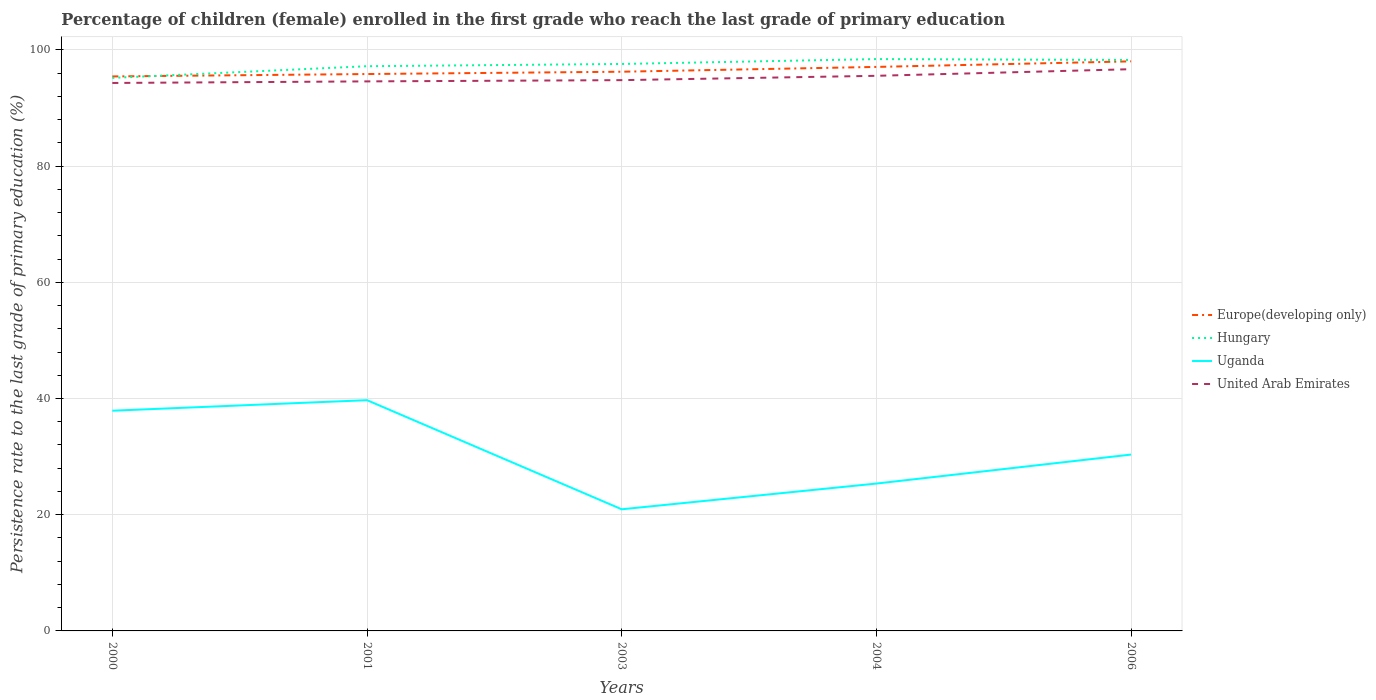Is the number of lines equal to the number of legend labels?
Make the answer very short. Yes. Across all years, what is the maximum persistence rate of children in Hungary?
Ensure brevity in your answer.  95.18. In which year was the persistence rate of children in United Arab Emirates maximum?
Give a very brief answer. 2000. What is the total persistence rate of children in United Arab Emirates in the graph?
Your answer should be compact. -0.75. What is the difference between the highest and the second highest persistence rate of children in Europe(developing only)?
Offer a terse response. 2.59. How many lines are there?
Offer a terse response. 4. How many years are there in the graph?
Ensure brevity in your answer.  5. Are the values on the major ticks of Y-axis written in scientific E-notation?
Your answer should be compact. No. Where does the legend appear in the graph?
Your answer should be very brief. Center right. What is the title of the graph?
Offer a very short reply. Percentage of children (female) enrolled in the first grade who reach the last grade of primary education. Does "Burundi" appear as one of the legend labels in the graph?
Offer a very short reply. No. What is the label or title of the X-axis?
Give a very brief answer. Years. What is the label or title of the Y-axis?
Your answer should be very brief. Persistence rate to the last grade of primary education (%). What is the Persistence rate to the last grade of primary education (%) of Europe(developing only) in 2000?
Your answer should be compact. 95.44. What is the Persistence rate to the last grade of primary education (%) in Hungary in 2000?
Your answer should be very brief. 95.18. What is the Persistence rate to the last grade of primary education (%) of Uganda in 2000?
Make the answer very short. 37.9. What is the Persistence rate to the last grade of primary education (%) in United Arab Emirates in 2000?
Offer a very short reply. 94.31. What is the Persistence rate to the last grade of primary education (%) in Europe(developing only) in 2001?
Your answer should be very brief. 95.85. What is the Persistence rate to the last grade of primary education (%) of Hungary in 2001?
Ensure brevity in your answer.  97.19. What is the Persistence rate to the last grade of primary education (%) in Uganda in 2001?
Provide a short and direct response. 39.72. What is the Persistence rate to the last grade of primary education (%) of United Arab Emirates in 2001?
Your answer should be very brief. 94.58. What is the Persistence rate to the last grade of primary education (%) in Europe(developing only) in 2003?
Provide a succinct answer. 96.25. What is the Persistence rate to the last grade of primary education (%) in Hungary in 2003?
Give a very brief answer. 97.58. What is the Persistence rate to the last grade of primary education (%) in Uganda in 2003?
Give a very brief answer. 20.93. What is the Persistence rate to the last grade of primary education (%) in United Arab Emirates in 2003?
Your response must be concise. 94.8. What is the Persistence rate to the last grade of primary education (%) in Europe(developing only) in 2004?
Keep it short and to the point. 97.07. What is the Persistence rate to the last grade of primary education (%) in Hungary in 2004?
Your answer should be compact. 98.42. What is the Persistence rate to the last grade of primary education (%) of Uganda in 2004?
Keep it short and to the point. 25.36. What is the Persistence rate to the last grade of primary education (%) of United Arab Emirates in 2004?
Provide a short and direct response. 95.54. What is the Persistence rate to the last grade of primary education (%) in Europe(developing only) in 2006?
Provide a succinct answer. 98.03. What is the Persistence rate to the last grade of primary education (%) in Hungary in 2006?
Provide a succinct answer. 98.27. What is the Persistence rate to the last grade of primary education (%) of Uganda in 2006?
Your answer should be compact. 30.35. What is the Persistence rate to the last grade of primary education (%) in United Arab Emirates in 2006?
Give a very brief answer. 96.68. Across all years, what is the maximum Persistence rate to the last grade of primary education (%) of Europe(developing only)?
Your answer should be very brief. 98.03. Across all years, what is the maximum Persistence rate to the last grade of primary education (%) in Hungary?
Your answer should be very brief. 98.42. Across all years, what is the maximum Persistence rate to the last grade of primary education (%) of Uganda?
Make the answer very short. 39.72. Across all years, what is the maximum Persistence rate to the last grade of primary education (%) of United Arab Emirates?
Give a very brief answer. 96.68. Across all years, what is the minimum Persistence rate to the last grade of primary education (%) of Europe(developing only)?
Give a very brief answer. 95.44. Across all years, what is the minimum Persistence rate to the last grade of primary education (%) of Hungary?
Make the answer very short. 95.18. Across all years, what is the minimum Persistence rate to the last grade of primary education (%) in Uganda?
Provide a succinct answer. 20.93. Across all years, what is the minimum Persistence rate to the last grade of primary education (%) in United Arab Emirates?
Provide a succinct answer. 94.31. What is the total Persistence rate to the last grade of primary education (%) in Europe(developing only) in the graph?
Give a very brief answer. 482.63. What is the total Persistence rate to the last grade of primary education (%) in Hungary in the graph?
Your response must be concise. 486.65. What is the total Persistence rate to the last grade of primary education (%) in Uganda in the graph?
Keep it short and to the point. 154.27. What is the total Persistence rate to the last grade of primary education (%) in United Arab Emirates in the graph?
Your answer should be very brief. 475.91. What is the difference between the Persistence rate to the last grade of primary education (%) in Europe(developing only) in 2000 and that in 2001?
Ensure brevity in your answer.  -0.41. What is the difference between the Persistence rate to the last grade of primary education (%) of Hungary in 2000 and that in 2001?
Offer a very short reply. -2.01. What is the difference between the Persistence rate to the last grade of primary education (%) in Uganda in 2000 and that in 2001?
Ensure brevity in your answer.  -1.82. What is the difference between the Persistence rate to the last grade of primary education (%) in United Arab Emirates in 2000 and that in 2001?
Offer a very short reply. -0.27. What is the difference between the Persistence rate to the last grade of primary education (%) in Europe(developing only) in 2000 and that in 2003?
Provide a succinct answer. -0.81. What is the difference between the Persistence rate to the last grade of primary education (%) of Hungary in 2000 and that in 2003?
Provide a short and direct response. -2.4. What is the difference between the Persistence rate to the last grade of primary education (%) in Uganda in 2000 and that in 2003?
Your answer should be compact. 16.96. What is the difference between the Persistence rate to the last grade of primary education (%) in United Arab Emirates in 2000 and that in 2003?
Give a very brief answer. -0.49. What is the difference between the Persistence rate to the last grade of primary education (%) of Europe(developing only) in 2000 and that in 2004?
Offer a terse response. -1.64. What is the difference between the Persistence rate to the last grade of primary education (%) in Hungary in 2000 and that in 2004?
Ensure brevity in your answer.  -3.24. What is the difference between the Persistence rate to the last grade of primary education (%) in Uganda in 2000 and that in 2004?
Your response must be concise. 12.53. What is the difference between the Persistence rate to the last grade of primary education (%) of United Arab Emirates in 2000 and that in 2004?
Your answer should be very brief. -1.23. What is the difference between the Persistence rate to the last grade of primary education (%) in Europe(developing only) in 2000 and that in 2006?
Your answer should be very brief. -2.59. What is the difference between the Persistence rate to the last grade of primary education (%) in Hungary in 2000 and that in 2006?
Offer a terse response. -3.09. What is the difference between the Persistence rate to the last grade of primary education (%) in Uganda in 2000 and that in 2006?
Offer a terse response. 7.55. What is the difference between the Persistence rate to the last grade of primary education (%) of United Arab Emirates in 2000 and that in 2006?
Offer a very short reply. -2.37. What is the difference between the Persistence rate to the last grade of primary education (%) in Europe(developing only) in 2001 and that in 2003?
Your answer should be compact. -0.4. What is the difference between the Persistence rate to the last grade of primary education (%) in Hungary in 2001 and that in 2003?
Offer a very short reply. -0.39. What is the difference between the Persistence rate to the last grade of primary education (%) in Uganda in 2001 and that in 2003?
Ensure brevity in your answer.  18.78. What is the difference between the Persistence rate to the last grade of primary education (%) in United Arab Emirates in 2001 and that in 2003?
Your answer should be very brief. -0.21. What is the difference between the Persistence rate to the last grade of primary education (%) of Europe(developing only) in 2001 and that in 2004?
Ensure brevity in your answer.  -1.23. What is the difference between the Persistence rate to the last grade of primary education (%) of Hungary in 2001 and that in 2004?
Keep it short and to the point. -1.23. What is the difference between the Persistence rate to the last grade of primary education (%) of Uganda in 2001 and that in 2004?
Ensure brevity in your answer.  14.35. What is the difference between the Persistence rate to the last grade of primary education (%) in United Arab Emirates in 2001 and that in 2004?
Ensure brevity in your answer.  -0.96. What is the difference between the Persistence rate to the last grade of primary education (%) in Europe(developing only) in 2001 and that in 2006?
Your answer should be compact. -2.18. What is the difference between the Persistence rate to the last grade of primary education (%) in Hungary in 2001 and that in 2006?
Provide a short and direct response. -1.07. What is the difference between the Persistence rate to the last grade of primary education (%) of Uganda in 2001 and that in 2006?
Ensure brevity in your answer.  9.36. What is the difference between the Persistence rate to the last grade of primary education (%) in United Arab Emirates in 2001 and that in 2006?
Offer a terse response. -2.1. What is the difference between the Persistence rate to the last grade of primary education (%) in Europe(developing only) in 2003 and that in 2004?
Provide a short and direct response. -0.83. What is the difference between the Persistence rate to the last grade of primary education (%) in Hungary in 2003 and that in 2004?
Give a very brief answer. -0.84. What is the difference between the Persistence rate to the last grade of primary education (%) in Uganda in 2003 and that in 2004?
Your answer should be compact. -4.43. What is the difference between the Persistence rate to the last grade of primary education (%) of United Arab Emirates in 2003 and that in 2004?
Keep it short and to the point. -0.75. What is the difference between the Persistence rate to the last grade of primary education (%) in Europe(developing only) in 2003 and that in 2006?
Your answer should be compact. -1.78. What is the difference between the Persistence rate to the last grade of primary education (%) in Hungary in 2003 and that in 2006?
Make the answer very short. -0.69. What is the difference between the Persistence rate to the last grade of primary education (%) in Uganda in 2003 and that in 2006?
Offer a terse response. -9.42. What is the difference between the Persistence rate to the last grade of primary education (%) of United Arab Emirates in 2003 and that in 2006?
Keep it short and to the point. -1.89. What is the difference between the Persistence rate to the last grade of primary education (%) in Europe(developing only) in 2004 and that in 2006?
Offer a terse response. -0.96. What is the difference between the Persistence rate to the last grade of primary education (%) in Hungary in 2004 and that in 2006?
Make the answer very short. 0.15. What is the difference between the Persistence rate to the last grade of primary education (%) of Uganda in 2004 and that in 2006?
Provide a succinct answer. -4.99. What is the difference between the Persistence rate to the last grade of primary education (%) of United Arab Emirates in 2004 and that in 2006?
Provide a succinct answer. -1.14. What is the difference between the Persistence rate to the last grade of primary education (%) of Europe(developing only) in 2000 and the Persistence rate to the last grade of primary education (%) of Hungary in 2001?
Give a very brief answer. -1.76. What is the difference between the Persistence rate to the last grade of primary education (%) of Europe(developing only) in 2000 and the Persistence rate to the last grade of primary education (%) of Uganda in 2001?
Provide a short and direct response. 55.72. What is the difference between the Persistence rate to the last grade of primary education (%) of Europe(developing only) in 2000 and the Persistence rate to the last grade of primary education (%) of United Arab Emirates in 2001?
Keep it short and to the point. 0.85. What is the difference between the Persistence rate to the last grade of primary education (%) of Hungary in 2000 and the Persistence rate to the last grade of primary education (%) of Uganda in 2001?
Make the answer very short. 55.47. What is the difference between the Persistence rate to the last grade of primary education (%) of Hungary in 2000 and the Persistence rate to the last grade of primary education (%) of United Arab Emirates in 2001?
Provide a succinct answer. 0.6. What is the difference between the Persistence rate to the last grade of primary education (%) in Uganda in 2000 and the Persistence rate to the last grade of primary education (%) in United Arab Emirates in 2001?
Provide a succinct answer. -56.68. What is the difference between the Persistence rate to the last grade of primary education (%) of Europe(developing only) in 2000 and the Persistence rate to the last grade of primary education (%) of Hungary in 2003?
Your response must be concise. -2.14. What is the difference between the Persistence rate to the last grade of primary education (%) in Europe(developing only) in 2000 and the Persistence rate to the last grade of primary education (%) in Uganda in 2003?
Offer a terse response. 74.5. What is the difference between the Persistence rate to the last grade of primary education (%) of Europe(developing only) in 2000 and the Persistence rate to the last grade of primary education (%) of United Arab Emirates in 2003?
Offer a terse response. 0.64. What is the difference between the Persistence rate to the last grade of primary education (%) in Hungary in 2000 and the Persistence rate to the last grade of primary education (%) in Uganda in 2003?
Ensure brevity in your answer.  74.25. What is the difference between the Persistence rate to the last grade of primary education (%) in Hungary in 2000 and the Persistence rate to the last grade of primary education (%) in United Arab Emirates in 2003?
Offer a terse response. 0.39. What is the difference between the Persistence rate to the last grade of primary education (%) of Uganda in 2000 and the Persistence rate to the last grade of primary education (%) of United Arab Emirates in 2003?
Give a very brief answer. -56.9. What is the difference between the Persistence rate to the last grade of primary education (%) in Europe(developing only) in 2000 and the Persistence rate to the last grade of primary education (%) in Hungary in 2004?
Make the answer very short. -2.98. What is the difference between the Persistence rate to the last grade of primary education (%) of Europe(developing only) in 2000 and the Persistence rate to the last grade of primary education (%) of Uganda in 2004?
Provide a succinct answer. 70.07. What is the difference between the Persistence rate to the last grade of primary education (%) in Europe(developing only) in 2000 and the Persistence rate to the last grade of primary education (%) in United Arab Emirates in 2004?
Offer a very short reply. -0.11. What is the difference between the Persistence rate to the last grade of primary education (%) of Hungary in 2000 and the Persistence rate to the last grade of primary education (%) of Uganda in 2004?
Keep it short and to the point. 69.82. What is the difference between the Persistence rate to the last grade of primary education (%) of Hungary in 2000 and the Persistence rate to the last grade of primary education (%) of United Arab Emirates in 2004?
Provide a short and direct response. -0.36. What is the difference between the Persistence rate to the last grade of primary education (%) of Uganda in 2000 and the Persistence rate to the last grade of primary education (%) of United Arab Emirates in 2004?
Offer a terse response. -57.64. What is the difference between the Persistence rate to the last grade of primary education (%) in Europe(developing only) in 2000 and the Persistence rate to the last grade of primary education (%) in Hungary in 2006?
Give a very brief answer. -2.83. What is the difference between the Persistence rate to the last grade of primary education (%) of Europe(developing only) in 2000 and the Persistence rate to the last grade of primary education (%) of Uganda in 2006?
Provide a short and direct response. 65.08. What is the difference between the Persistence rate to the last grade of primary education (%) of Europe(developing only) in 2000 and the Persistence rate to the last grade of primary education (%) of United Arab Emirates in 2006?
Provide a short and direct response. -1.24. What is the difference between the Persistence rate to the last grade of primary education (%) of Hungary in 2000 and the Persistence rate to the last grade of primary education (%) of Uganda in 2006?
Your response must be concise. 64.83. What is the difference between the Persistence rate to the last grade of primary education (%) of Hungary in 2000 and the Persistence rate to the last grade of primary education (%) of United Arab Emirates in 2006?
Keep it short and to the point. -1.5. What is the difference between the Persistence rate to the last grade of primary education (%) of Uganda in 2000 and the Persistence rate to the last grade of primary education (%) of United Arab Emirates in 2006?
Ensure brevity in your answer.  -58.78. What is the difference between the Persistence rate to the last grade of primary education (%) in Europe(developing only) in 2001 and the Persistence rate to the last grade of primary education (%) in Hungary in 2003?
Your answer should be compact. -1.73. What is the difference between the Persistence rate to the last grade of primary education (%) of Europe(developing only) in 2001 and the Persistence rate to the last grade of primary education (%) of Uganda in 2003?
Keep it short and to the point. 74.91. What is the difference between the Persistence rate to the last grade of primary education (%) in Europe(developing only) in 2001 and the Persistence rate to the last grade of primary education (%) in United Arab Emirates in 2003?
Your answer should be compact. 1.05. What is the difference between the Persistence rate to the last grade of primary education (%) in Hungary in 2001 and the Persistence rate to the last grade of primary education (%) in Uganda in 2003?
Offer a very short reply. 76.26. What is the difference between the Persistence rate to the last grade of primary education (%) of Hungary in 2001 and the Persistence rate to the last grade of primary education (%) of United Arab Emirates in 2003?
Provide a short and direct response. 2.4. What is the difference between the Persistence rate to the last grade of primary education (%) of Uganda in 2001 and the Persistence rate to the last grade of primary education (%) of United Arab Emirates in 2003?
Your answer should be very brief. -55.08. What is the difference between the Persistence rate to the last grade of primary education (%) of Europe(developing only) in 2001 and the Persistence rate to the last grade of primary education (%) of Hungary in 2004?
Provide a short and direct response. -2.57. What is the difference between the Persistence rate to the last grade of primary education (%) in Europe(developing only) in 2001 and the Persistence rate to the last grade of primary education (%) in Uganda in 2004?
Your answer should be very brief. 70.48. What is the difference between the Persistence rate to the last grade of primary education (%) of Europe(developing only) in 2001 and the Persistence rate to the last grade of primary education (%) of United Arab Emirates in 2004?
Offer a terse response. 0.3. What is the difference between the Persistence rate to the last grade of primary education (%) in Hungary in 2001 and the Persistence rate to the last grade of primary education (%) in Uganda in 2004?
Provide a short and direct response. 71.83. What is the difference between the Persistence rate to the last grade of primary education (%) in Hungary in 2001 and the Persistence rate to the last grade of primary education (%) in United Arab Emirates in 2004?
Provide a short and direct response. 1.65. What is the difference between the Persistence rate to the last grade of primary education (%) of Uganda in 2001 and the Persistence rate to the last grade of primary education (%) of United Arab Emirates in 2004?
Keep it short and to the point. -55.83. What is the difference between the Persistence rate to the last grade of primary education (%) of Europe(developing only) in 2001 and the Persistence rate to the last grade of primary education (%) of Hungary in 2006?
Give a very brief answer. -2.42. What is the difference between the Persistence rate to the last grade of primary education (%) in Europe(developing only) in 2001 and the Persistence rate to the last grade of primary education (%) in Uganda in 2006?
Give a very brief answer. 65.49. What is the difference between the Persistence rate to the last grade of primary education (%) in Europe(developing only) in 2001 and the Persistence rate to the last grade of primary education (%) in United Arab Emirates in 2006?
Keep it short and to the point. -0.83. What is the difference between the Persistence rate to the last grade of primary education (%) in Hungary in 2001 and the Persistence rate to the last grade of primary education (%) in Uganda in 2006?
Keep it short and to the point. 66.84. What is the difference between the Persistence rate to the last grade of primary education (%) in Hungary in 2001 and the Persistence rate to the last grade of primary education (%) in United Arab Emirates in 2006?
Your answer should be compact. 0.51. What is the difference between the Persistence rate to the last grade of primary education (%) in Uganda in 2001 and the Persistence rate to the last grade of primary education (%) in United Arab Emirates in 2006?
Keep it short and to the point. -56.97. What is the difference between the Persistence rate to the last grade of primary education (%) in Europe(developing only) in 2003 and the Persistence rate to the last grade of primary education (%) in Hungary in 2004?
Provide a short and direct response. -2.17. What is the difference between the Persistence rate to the last grade of primary education (%) in Europe(developing only) in 2003 and the Persistence rate to the last grade of primary education (%) in Uganda in 2004?
Your response must be concise. 70.88. What is the difference between the Persistence rate to the last grade of primary education (%) in Europe(developing only) in 2003 and the Persistence rate to the last grade of primary education (%) in United Arab Emirates in 2004?
Give a very brief answer. 0.7. What is the difference between the Persistence rate to the last grade of primary education (%) in Hungary in 2003 and the Persistence rate to the last grade of primary education (%) in Uganda in 2004?
Provide a short and direct response. 72.22. What is the difference between the Persistence rate to the last grade of primary education (%) in Hungary in 2003 and the Persistence rate to the last grade of primary education (%) in United Arab Emirates in 2004?
Your response must be concise. 2.04. What is the difference between the Persistence rate to the last grade of primary education (%) in Uganda in 2003 and the Persistence rate to the last grade of primary education (%) in United Arab Emirates in 2004?
Your answer should be compact. -74.61. What is the difference between the Persistence rate to the last grade of primary education (%) of Europe(developing only) in 2003 and the Persistence rate to the last grade of primary education (%) of Hungary in 2006?
Keep it short and to the point. -2.02. What is the difference between the Persistence rate to the last grade of primary education (%) in Europe(developing only) in 2003 and the Persistence rate to the last grade of primary education (%) in Uganda in 2006?
Offer a terse response. 65.89. What is the difference between the Persistence rate to the last grade of primary education (%) in Europe(developing only) in 2003 and the Persistence rate to the last grade of primary education (%) in United Arab Emirates in 2006?
Keep it short and to the point. -0.44. What is the difference between the Persistence rate to the last grade of primary education (%) in Hungary in 2003 and the Persistence rate to the last grade of primary education (%) in Uganda in 2006?
Make the answer very short. 67.23. What is the difference between the Persistence rate to the last grade of primary education (%) of Hungary in 2003 and the Persistence rate to the last grade of primary education (%) of United Arab Emirates in 2006?
Make the answer very short. 0.9. What is the difference between the Persistence rate to the last grade of primary education (%) in Uganda in 2003 and the Persistence rate to the last grade of primary education (%) in United Arab Emirates in 2006?
Keep it short and to the point. -75.75. What is the difference between the Persistence rate to the last grade of primary education (%) of Europe(developing only) in 2004 and the Persistence rate to the last grade of primary education (%) of Hungary in 2006?
Offer a very short reply. -1.2. What is the difference between the Persistence rate to the last grade of primary education (%) of Europe(developing only) in 2004 and the Persistence rate to the last grade of primary education (%) of Uganda in 2006?
Offer a terse response. 66.72. What is the difference between the Persistence rate to the last grade of primary education (%) of Europe(developing only) in 2004 and the Persistence rate to the last grade of primary education (%) of United Arab Emirates in 2006?
Provide a short and direct response. 0.39. What is the difference between the Persistence rate to the last grade of primary education (%) in Hungary in 2004 and the Persistence rate to the last grade of primary education (%) in Uganda in 2006?
Provide a short and direct response. 68.07. What is the difference between the Persistence rate to the last grade of primary education (%) in Hungary in 2004 and the Persistence rate to the last grade of primary education (%) in United Arab Emirates in 2006?
Make the answer very short. 1.74. What is the difference between the Persistence rate to the last grade of primary education (%) of Uganda in 2004 and the Persistence rate to the last grade of primary education (%) of United Arab Emirates in 2006?
Make the answer very short. -71.32. What is the average Persistence rate to the last grade of primary education (%) in Europe(developing only) per year?
Your answer should be very brief. 96.53. What is the average Persistence rate to the last grade of primary education (%) of Hungary per year?
Make the answer very short. 97.33. What is the average Persistence rate to the last grade of primary education (%) in Uganda per year?
Provide a short and direct response. 30.85. What is the average Persistence rate to the last grade of primary education (%) in United Arab Emirates per year?
Make the answer very short. 95.18. In the year 2000, what is the difference between the Persistence rate to the last grade of primary education (%) in Europe(developing only) and Persistence rate to the last grade of primary education (%) in Hungary?
Your answer should be very brief. 0.26. In the year 2000, what is the difference between the Persistence rate to the last grade of primary education (%) in Europe(developing only) and Persistence rate to the last grade of primary education (%) in Uganda?
Keep it short and to the point. 57.54. In the year 2000, what is the difference between the Persistence rate to the last grade of primary education (%) in Europe(developing only) and Persistence rate to the last grade of primary education (%) in United Arab Emirates?
Ensure brevity in your answer.  1.13. In the year 2000, what is the difference between the Persistence rate to the last grade of primary education (%) of Hungary and Persistence rate to the last grade of primary education (%) of Uganda?
Offer a terse response. 57.28. In the year 2000, what is the difference between the Persistence rate to the last grade of primary education (%) of Hungary and Persistence rate to the last grade of primary education (%) of United Arab Emirates?
Make the answer very short. 0.87. In the year 2000, what is the difference between the Persistence rate to the last grade of primary education (%) of Uganda and Persistence rate to the last grade of primary education (%) of United Arab Emirates?
Offer a very short reply. -56.41. In the year 2001, what is the difference between the Persistence rate to the last grade of primary education (%) in Europe(developing only) and Persistence rate to the last grade of primary education (%) in Hungary?
Keep it short and to the point. -1.35. In the year 2001, what is the difference between the Persistence rate to the last grade of primary education (%) of Europe(developing only) and Persistence rate to the last grade of primary education (%) of Uganda?
Provide a succinct answer. 56.13. In the year 2001, what is the difference between the Persistence rate to the last grade of primary education (%) in Europe(developing only) and Persistence rate to the last grade of primary education (%) in United Arab Emirates?
Your answer should be very brief. 1.26. In the year 2001, what is the difference between the Persistence rate to the last grade of primary education (%) in Hungary and Persistence rate to the last grade of primary education (%) in Uganda?
Keep it short and to the point. 57.48. In the year 2001, what is the difference between the Persistence rate to the last grade of primary education (%) of Hungary and Persistence rate to the last grade of primary education (%) of United Arab Emirates?
Give a very brief answer. 2.61. In the year 2001, what is the difference between the Persistence rate to the last grade of primary education (%) of Uganda and Persistence rate to the last grade of primary education (%) of United Arab Emirates?
Your answer should be very brief. -54.87. In the year 2003, what is the difference between the Persistence rate to the last grade of primary education (%) of Europe(developing only) and Persistence rate to the last grade of primary education (%) of Hungary?
Make the answer very short. -1.33. In the year 2003, what is the difference between the Persistence rate to the last grade of primary education (%) in Europe(developing only) and Persistence rate to the last grade of primary education (%) in Uganda?
Give a very brief answer. 75.31. In the year 2003, what is the difference between the Persistence rate to the last grade of primary education (%) in Europe(developing only) and Persistence rate to the last grade of primary education (%) in United Arab Emirates?
Your response must be concise. 1.45. In the year 2003, what is the difference between the Persistence rate to the last grade of primary education (%) of Hungary and Persistence rate to the last grade of primary education (%) of Uganda?
Offer a terse response. 76.65. In the year 2003, what is the difference between the Persistence rate to the last grade of primary education (%) of Hungary and Persistence rate to the last grade of primary education (%) of United Arab Emirates?
Your answer should be very brief. 2.78. In the year 2003, what is the difference between the Persistence rate to the last grade of primary education (%) of Uganda and Persistence rate to the last grade of primary education (%) of United Arab Emirates?
Provide a succinct answer. -73.86. In the year 2004, what is the difference between the Persistence rate to the last grade of primary education (%) of Europe(developing only) and Persistence rate to the last grade of primary education (%) of Hungary?
Your answer should be compact. -1.35. In the year 2004, what is the difference between the Persistence rate to the last grade of primary education (%) of Europe(developing only) and Persistence rate to the last grade of primary education (%) of Uganda?
Offer a very short reply. 71.71. In the year 2004, what is the difference between the Persistence rate to the last grade of primary education (%) in Europe(developing only) and Persistence rate to the last grade of primary education (%) in United Arab Emirates?
Offer a very short reply. 1.53. In the year 2004, what is the difference between the Persistence rate to the last grade of primary education (%) of Hungary and Persistence rate to the last grade of primary education (%) of Uganda?
Your answer should be compact. 73.06. In the year 2004, what is the difference between the Persistence rate to the last grade of primary education (%) of Hungary and Persistence rate to the last grade of primary education (%) of United Arab Emirates?
Provide a succinct answer. 2.88. In the year 2004, what is the difference between the Persistence rate to the last grade of primary education (%) in Uganda and Persistence rate to the last grade of primary education (%) in United Arab Emirates?
Provide a succinct answer. -70.18. In the year 2006, what is the difference between the Persistence rate to the last grade of primary education (%) in Europe(developing only) and Persistence rate to the last grade of primary education (%) in Hungary?
Offer a very short reply. -0.24. In the year 2006, what is the difference between the Persistence rate to the last grade of primary education (%) in Europe(developing only) and Persistence rate to the last grade of primary education (%) in Uganda?
Your answer should be very brief. 67.68. In the year 2006, what is the difference between the Persistence rate to the last grade of primary education (%) of Europe(developing only) and Persistence rate to the last grade of primary education (%) of United Arab Emirates?
Provide a succinct answer. 1.35. In the year 2006, what is the difference between the Persistence rate to the last grade of primary education (%) of Hungary and Persistence rate to the last grade of primary education (%) of Uganda?
Make the answer very short. 67.92. In the year 2006, what is the difference between the Persistence rate to the last grade of primary education (%) of Hungary and Persistence rate to the last grade of primary education (%) of United Arab Emirates?
Provide a short and direct response. 1.59. In the year 2006, what is the difference between the Persistence rate to the last grade of primary education (%) in Uganda and Persistence rate to the last grade of primary education (%) in United Arab Emirates?
Provide a succinct answer. -66.33. What is the ratio of the Persistence rate to the last grade of primary education (%) in Europe(developing only) in 2000 to that in 2001?
Your response must be concise. 1. What is the ratio of the Persistence rate to the last grade of primary education (%) in Hungary in 2000 to that in 2001?
Offer a terse response. 0.98. What is the ratio of the Persistence rate to the last grade of primary education (%) in Uganda in 2000 to that in 2001?
Offer a very short reply. 0.95. What is the ratio of the Persistence rate to the last grade of primary education (%) of Europe(developing only) in 2000 to that in 2003?
Offer a terse response. 0.99. What is the ratio of the Persistence rate to the last grade of primary education (%) of Hungary in 2000 to that in 2003?
Keep it short and to the point. 0.98. What is the ratio of the Persistence rate to the last grade of primary education (%) of Uganda in 2000 to that in 2003?
Offer a terse response. 1.81. What is the ratio of the Persistence rate to the last grade of primary education (%) of Europe(developing only) in 2000 to that in 2004?
Offer a terse response. 0.98. What is the ratio of the Persistence rate to the last grade of primary education (%) in Hungary in 2000 to that in 2004?
Keep it short and to the point. 0.97. What is the ratio of the Persistence rate to the last grade of primary education (%) in Uganda in 2000 to that in 2004?
Your answer should be very brief. 1.49. What is the ratio of the Persistence rate to the last grade of primary education (%) of United Arab Emirates in 2000 to that in 2004?
Provide a succinct answer. 0.99. What is the ratio of the Persistence rate to the last grade of primary education (%) in Europe(developing only) in 2000 to that in 2006?
Provide a short and direct response. 0.97. What is the ratio of the Persistence rate to the last grade of primary education (%) in Hungary in 2000 to that in 2006?
Make the answer very short. 0.97. What is the ratio of the Persistence rate to the last grade of primary education (%) in Uganda in 2000 to that in 2006?
Give a very brief answer. 1.25. What is the ratio of the Persistence rate to the last grade of primary education (%) of United Arab Emirates in 2000 to that in 2006?
Offer a very short reply. 0.98. What is the ratio of the Persistence rate to the last grade of primary education (%) in Hungary in 2001 to that in 2003?
Your answer should be very brief. 1. What is the ratio of the Persistence rate to the last grade of primary education (%) in Uganda in 2001 to that in 2003?
Keep it short and to the point. 1.9. What is the ratio of the Persistence rate to the last grade of primary education (%) of United Arab Emirates in 2001 to that in 2003?
Your answer should be compact. 1. What is the ratio of the Persistence rate to the last grade of primary education (%) of Europe(developing only) in 2001 to that in 2004?
Offer a terse response. 0.99. What is the ratio of the Persistence rate to the last grade of primary education (%) in Hungary in 2001 to that in 2004?
Ensure brevity in your answer.  0.99. What is the ratio of the Persistence rate to the last grade of primary education (%) of Uganda in 2001 to that in 2004?
Keep it short and to the point. 1.57. What is the ratio of the Persistence rate to the last grade of primary education (%) of Europe(developing only) in 2001 to that in 2006?
Your answer should be very brief. 0.98. What is the ratio of the Persistence rate to the last grade of primary education (%) in Hungary in 2001 to that in 2006?
Your answer should be very brief. 0.99. What is the ratio of the Persistence rate to the last grade of primary education (%) of Uganda in 2001 to that in 2006?
Offer a very short reply. 1.31. What is the ratio of the Persistence rate to the last grade of primary education (%) in United Arab Emirates in 2001 to that in 2006?
Make the answer very short. 0.98. What is the ratio of the Persistence rate to the last grade of primary education (%) of Europe(developing only) in 2003 to that in 2004?
Offer a very short reply. 0.99. What is the ratio of the Persistence rate to the last grade of primary education (%) of Uganda in 2003 to that in 2004?
Offer a very short reply. 0.83. What is the ratio of the Persistence rate to the last grade of primary education (%) in United Arab Emirates in 2003 to that in 2004?
Provide a succinct answer. 0.99. What is the ratio of the Persistence rate to the last grade of primary education (%) of Europe(developing only) in 2003 to that in 2006?
Make the answer very short. 0.98. What is the ratio of the Persistence rate to the last grade of primary education (%) of Hungary in 2003 to that in 2006?
Provide a succinct answer. 0.99. What is the ratio of the Persistence rate to the last grade of primary education (%) of Uganda in 2003 to that in 2006?
Provide a short and direct response. 0.69. What is the ratio of the Persistence rate to the last grade of primary education (%) of United Arab Emirates in 2003 to that in 2006?
Offer a very short reply. 0.98. What is the ratio of the Persistence rate to the last grade of primary education (%) in Europe(developing only) in 2004 to that in 2006?
Make the answer very short. 0.99. What is the ratio of the Persistence rate to the last grade of primary education (%) in Uganda in 2004 to that in 2006?
Your answer should be very brief. 0.84. What is the difference between the highest and the second highest Persistence rate to the last grade of primary education (%) in Europe(developing only)?
Make the answer very short. 0.96. What is the difference between the highest and the second highest Persistence rate to the last grade of primary education (%) in Hungary?
Give a very brief answer. 0.15. What is the difference between the highest and the second highest Persistence rate to the last grade of primary education (%) of Uganda?
Your answer should be very brief. 1.82. What is the difference between the highest and the second highest Persistence rate to the last grade of primary education (%) in United Arab Emirates?
Your answer should be compact. 1.14. What is the difference between the highest and the lowest Persistence rate to the last grade of primary education (%) of Europe(developing only)?
Keep it short and to the point. 2.59. What is the difference between the highest and the lowest Persistence rate to the last grade of primary education (%) of Hungary?
Make the answer very short. 3.24. What is the difference between the highest and the lowest Persistence rate to the last grade of primary education (%) of Uganda?
Your answer should be very brief. 18.78. What is the difference between the highest and the lowest Persistence rate to the last grade of primary education (%) in United Arab Emirates?
Make the answer very short. 2.37. 